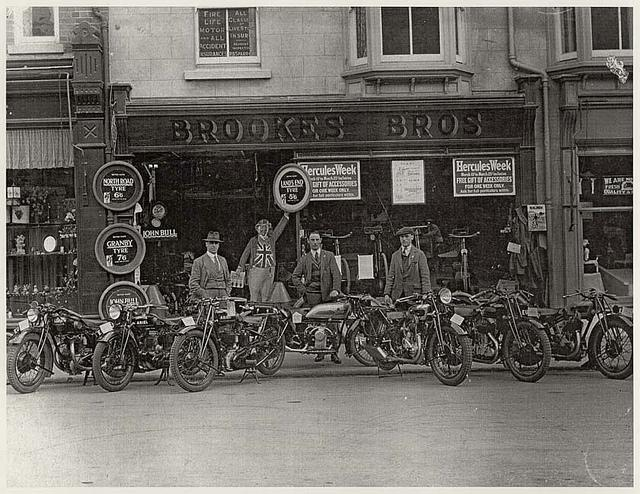What countries flag can be seen on the man's shirt?

Choices:
A) australia
B) united kingdom
C) china
D) africa united kingdom 